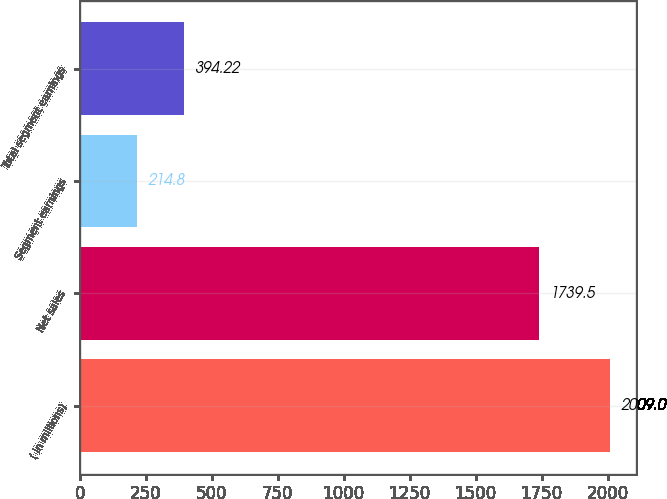<chart> <loc_0><loc_0><loc_500><loc_500><bar_chart><fcel>( in millions)<fcel>Net sales<fcel>Segment earnings<fcel>Total segment earnings<nl><fcel>2009<fcel>1739.5<fcel>214.8<fcel>394.22<nl></chart> 